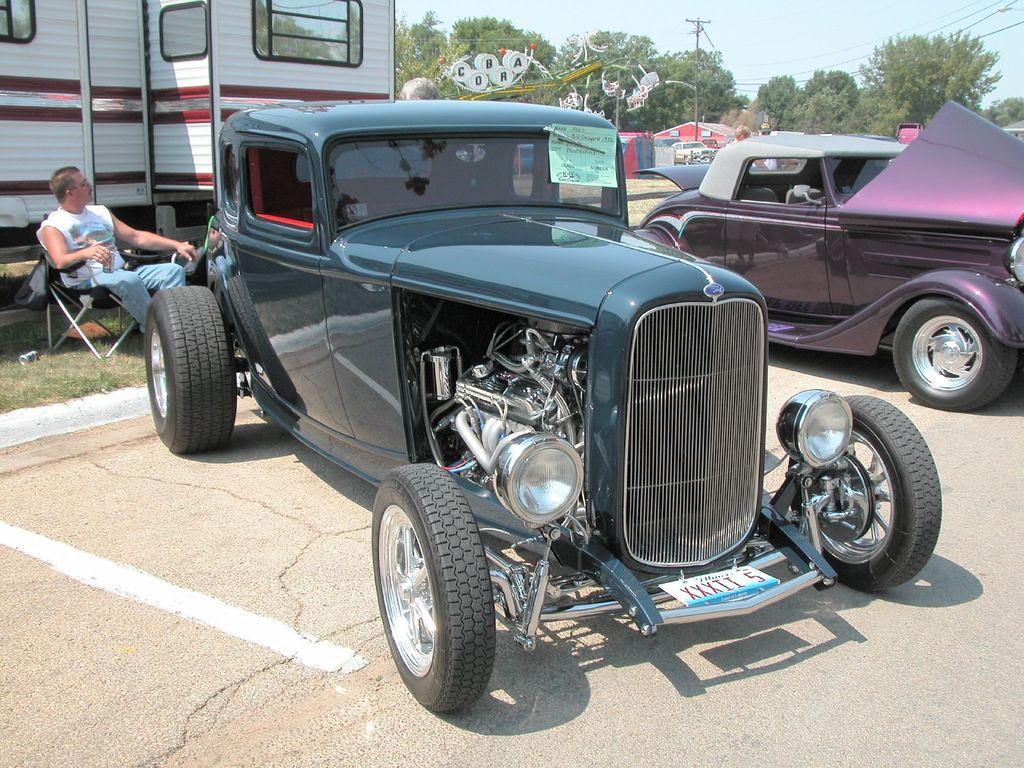How would you summarize this image in a sentence or two? There are vehicles,a person sitting on the chair,trees,poles and sky in this picture. 